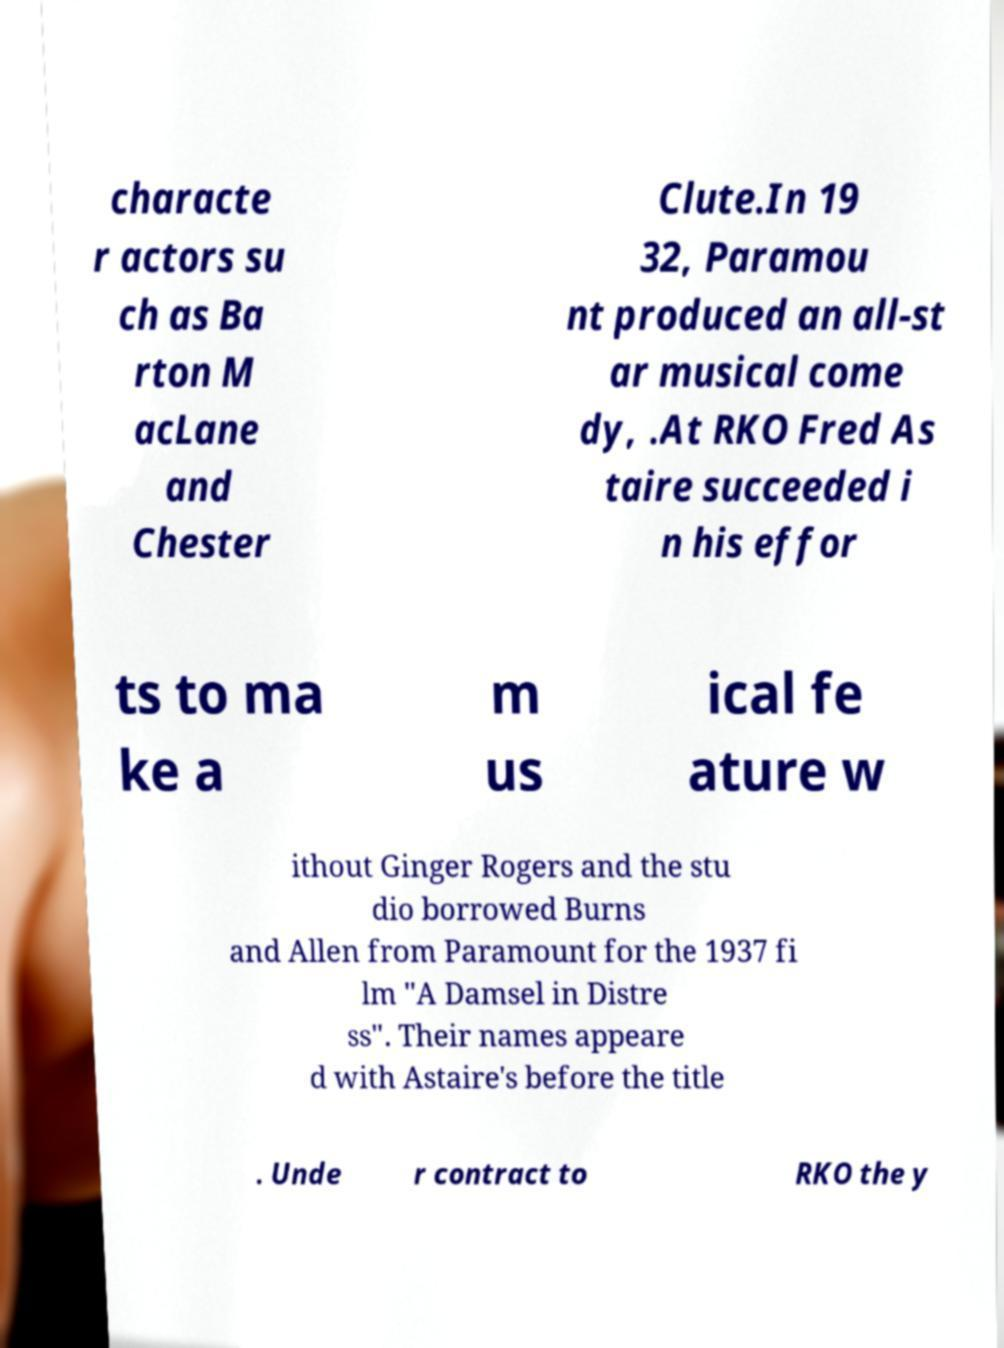There's text embedded in this image that I need extracted. Can you transcribe it verbatim? characte r actors su ch as Ba rton M acLane and Chester Clute.In 19 32, Paramou nt produced an all-st ar musical come dy, .At RKO Fred As taire succeeded i n his effor ts to ma ke a m us ical fe ature w ithout Ginger Rogers and the stu dio borrowed Burns and Allen from Paramount for the 1937 fi lm "A Damsel in Distre ss". Their names appeare d with Astaire's before the title . Unde r contract to RKO the y 